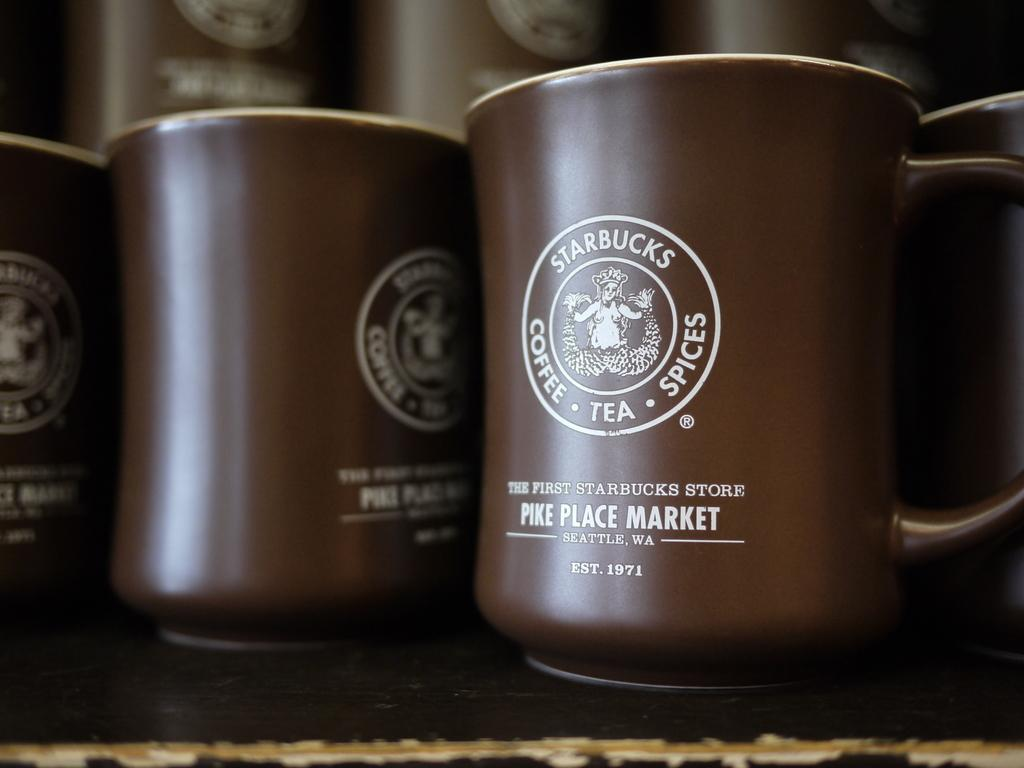<image>
Relay a brief, clear account of the picture shown. Some brown mugs from Starbucks say, "Pike Place Market". 